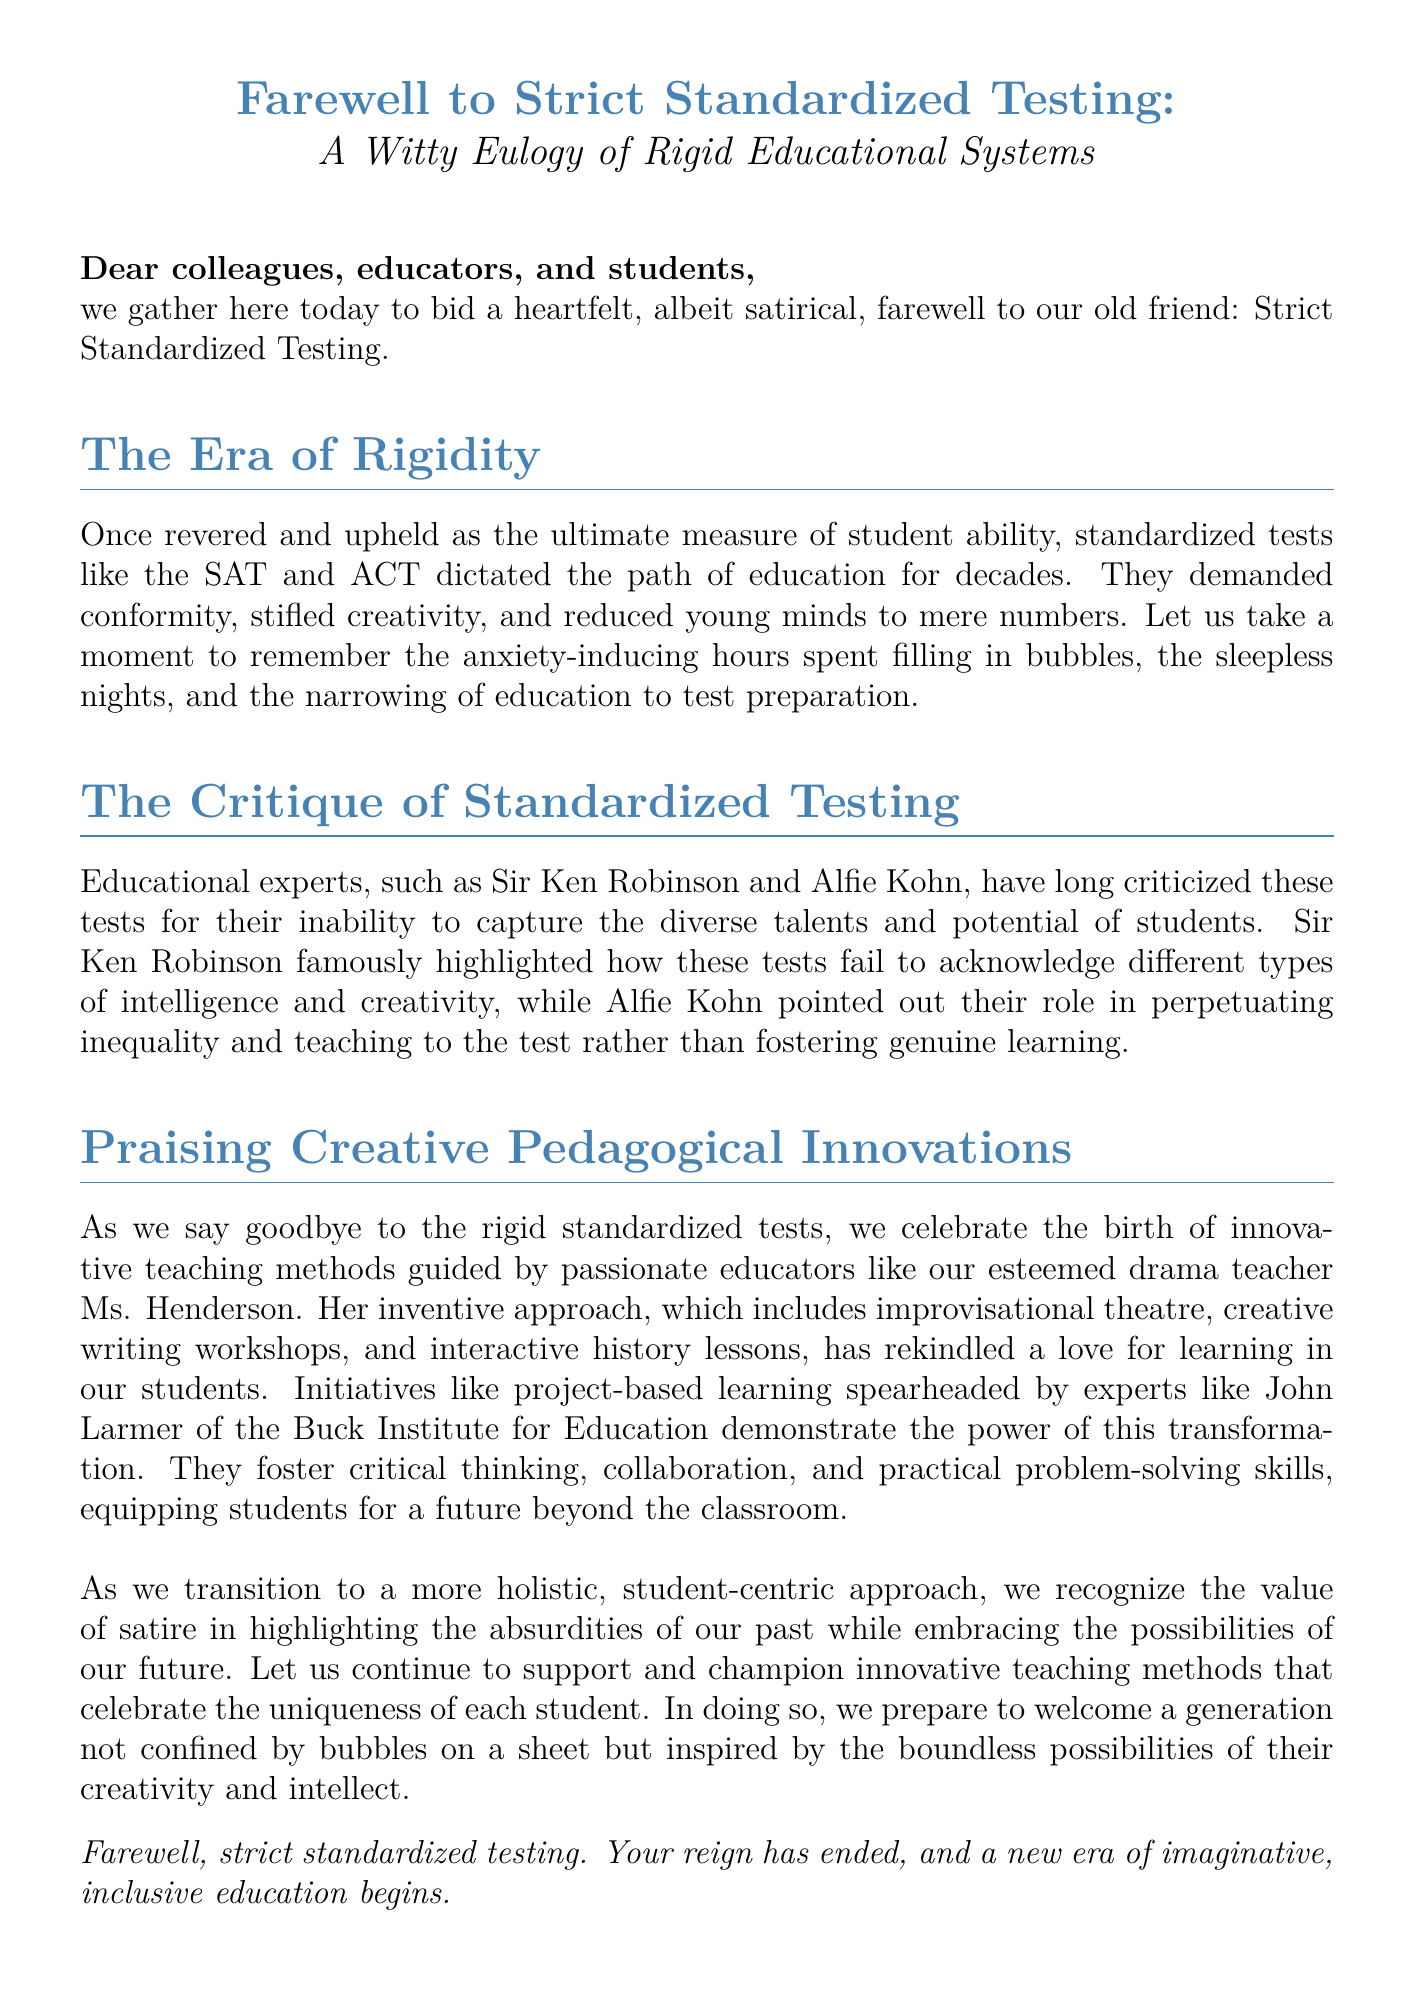What is the primary subject of the eulogy? The primary subject of the eulogy is the farewell to Strict Standardized Testing.
Answer: Strict Standardized Testing Who are two educational experts mentioned in the document? The two educational experts mentioned are Sir Ken Robinson and Alfie Kohn.
Answer: Sir Ken Robinson and Alfie Kohn What pedagogical method does Ms. Henderson employ in her teaching? Ms. Henderson employs improvisational theatre and creative writing workshops in her teaching methods.
Answer: Improvisational theatre What does the eulogy criticize about standardized tests? The eulogy criticizes standardized tests for demanding conformity and stifling creativity.
Answer: Demanding conformity and stifling creativity Which institution is mentioned in relation to project-based learning? The Buck Institute for Education is mentioned in relation to project-based learning.
Answer: Buck Institute for Education What transformation does the document advocate for in education? The document advocates for a transition to a more holistic, student-centric approach in education.
Answer: A more holistic, student-centric approach What does the eulogy suggest prepares students for the future? The eulogy suggests that innovative teaching methods and creativity prepare students for the future.
Answer: Innovative teaching methods and creativity What phrase summarizes the end of an era mentioned in the eulogy? The phrase summarizing the end of an era is "Your reign has ended."
Answer: Your reign has ended 